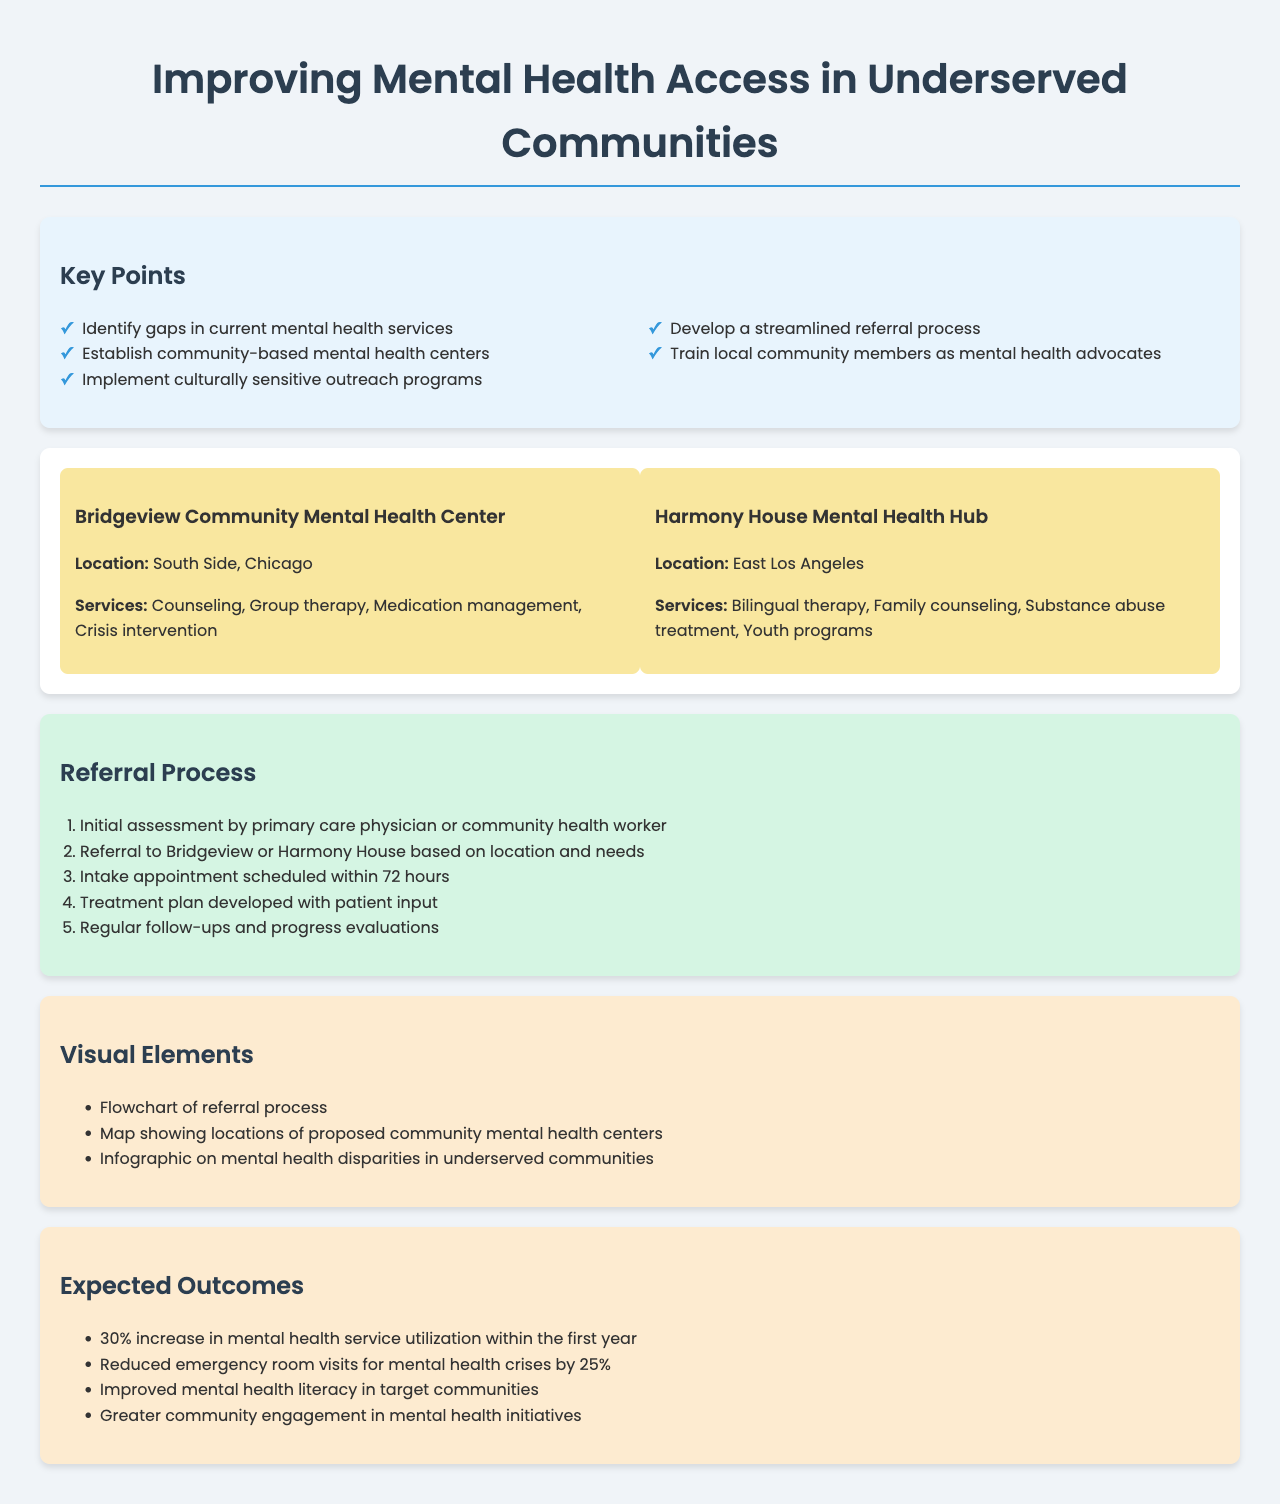What is the title of the policy document? The title is stated at the top of the document.
Answer: Improving Mental Health Access in Underserved Communities What is one of the key points mentioned in the document? The key points are listed in the designated section.
Answer: Establish community-based mental health centers What services will the Bridgeview Community Mental Health Center provide? The services are detailed under each proposed center.
Answer: Counseling, Group therapy, Medication management, Crisis intervention What is the expected increase in mental health service utilization within the first year? The expected outcomes provide a specific statistic.
Answer: 30% How many days are allocated for scheduling an intake appointment? The referral process outlines the timeframe for this step.
Answer: 72 hours Which location is the Harmony House Mental Health Hub situated in? The location is specified in the section about the proposed centers.
Answer: East Los Angeles What is the first step in the referral process? The referral process outlines the sequence of steps.
Answer: Initial assessment by primary care physician or community health worker What is one visual element included in the document? The visual elements are listed in their respective section.
Answer: Flowchart of referral process What percentage reduction in emergency room visits for mental health crises is expected? The document lists expected outcomes, including this statistic.
Answer: 25% 